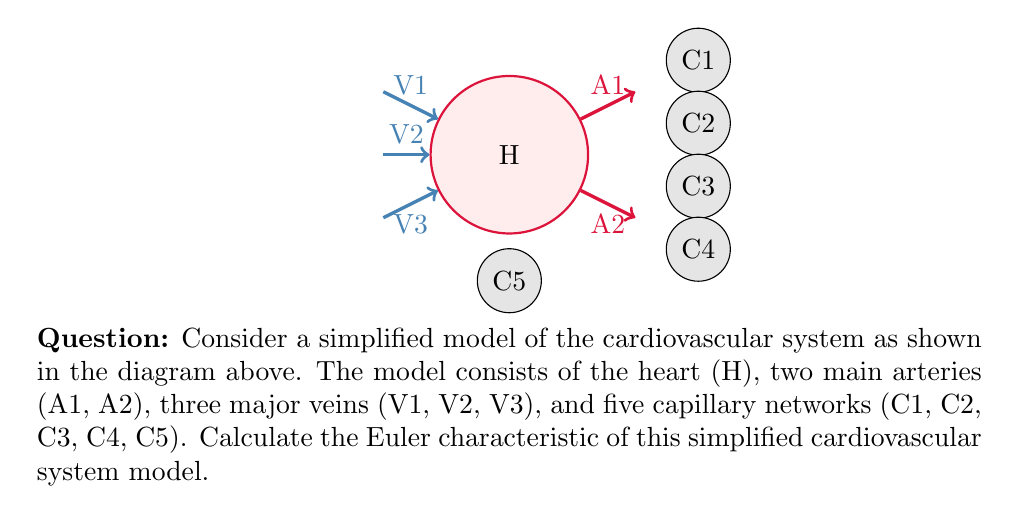Can you solve this math problem? To calculate the Euler characteristic of this simplified cardiovascular system model, we need to use the formula:

$$\chi = V - E + F$$

Where:
$\chi$ is the Euler characteristic
$V$ is the number of vertices
$E$ is the number of edges
$F$ is the number of faces

Let's count each component:

1. Vertices (V):
   - 1 heart
   - 2 arteries
   - 3 veins
   - 5 capillary networks
   Total vertices: $V = 1 + 2 + 3 + 5 = 11$

2. Edges (E):
   - 2 connections from heart to arteries
   - 3 connections from veins to heart
   - 5 connections from arteries to capillaries (assuming each capillary is connected to an artery)
   Total edges: $E = 2 + 3 + 5 = 10$

3. Faces (F):
   In this 2D representation, there are no enclosed faces, so $F = 0$

Now we can apply the formula:

$$\chi = V - E + F$$
$$\chi = 11 - 10 + 0$$
$$\chi = 1$$

Therefore, the Euler characteristic of this simplified cardiovascular system model is 1.
Answer: $\chi = 1$ 